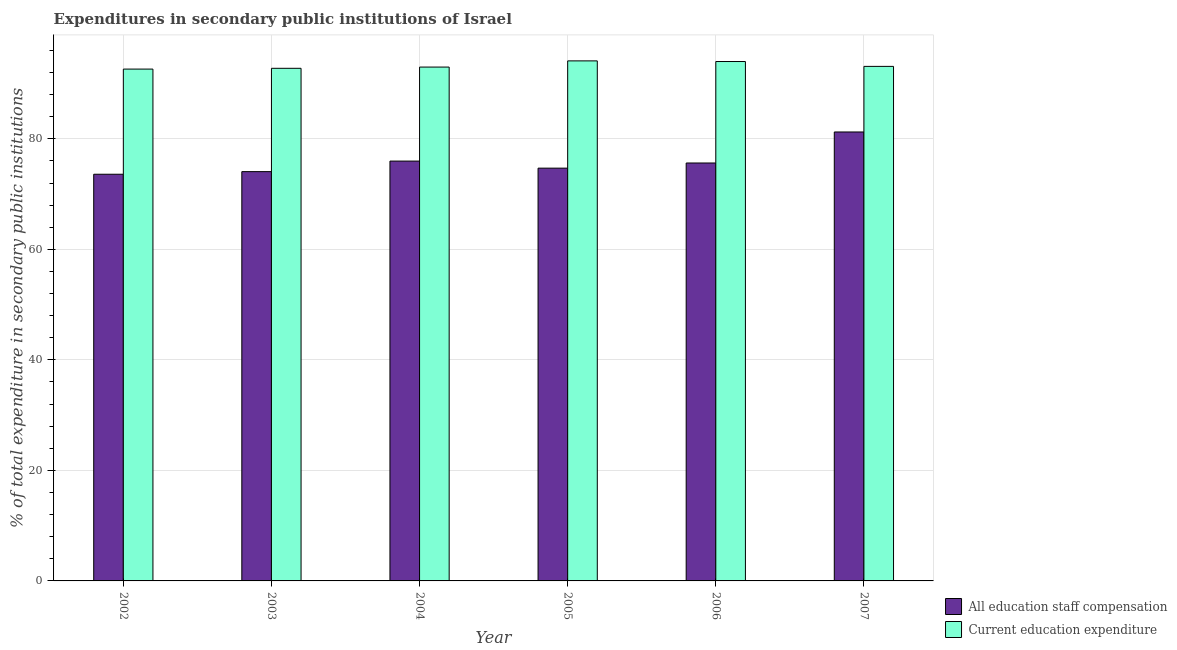How many different coloured bars are there?
Offer a very short reply. 2. How many groups of bars are there?
Your response must be concise. 6. Are the number of bars per tick equal to the number of legend labels?
Give a very brief answer. Yes. How many bars are there on the 2nd tick from the right?
Make the answer very short. 2. In how many cases, is the number of bars for a given year not equal to the number of legend labels?
Provide a succinct answer. 0. What is the expenditure in education in 2002?
Give a very brief answer. 92.62. Across all years, what is the maximum expenditure in education?
Offer a very short reply. 94.11. Across all years, what is the minimum expenditure in staff compensation?
Provide a short and direct response. 73.59. In which year was the expenditure in education maximum?
Provide a short and direct response. 2005. In which year was the expenditure in education minimum?
Your response must be concise. 2002. What is the total expenditure in education in the graph?
Make the answer very short. 559.59. What is the difference between the expenditure in staff compensation in 2006 and that in 2007?
Provide a succinct answer. -5.61. What is the difference between the expenditure in education in 2003 and the expenditure in staff compensation in 2002?
Your answer should be compact. 0.14. What is the average expenditure in education per year?
Keep it short and to the point. 93.27. In the year 2002, what is the difference between the expenditure in education and expenditure in staff compensation?
Provide a short and direct response. 0. In how many years, is the expenditure in staff compensation greater than 56 %?
Provide a short and direct response. 6. What is the ratio of the expenditure in staff compensation in 2003 to that in 2007?
Ensure brevity in your answer.  0.91. Is the expenditure in education in 2006 less than that in 2007?
Make the answer very short. No. What is the difference between the highest and the second highest expenditure in education?
Offer a very short reply. 0.12. What is the difference between the highest and the lowest expenditure in education?
Ensure brevity in your answer.  1.49. What does the 1st bar from the left in 2003 represents?
Offer a terse response. All education staff compensation. What does the 2nd bar from the right in 2003 represents?
Provide a short and direct response. All education staff compensation. How many bars are there?
Offer a terse response. 12. How many years are there in the graph?
Make the answer very short. 6. Are the values on the major ticks of Y-axis written in scientific E-notation?
Your answer should be compact. No. Where does the legend appear in the graph?
Your response must be concise. Bottom right. What is the title of the graph?
Your answer should be very brief. Expenditures in secondary public institutions of Israel. Does "DAC donors" appear as one of the legend labels in the graph?
Ensure brevity in your answer.  No. What is the label or title of the X-axis?
Provide a short and direct response. Year. What is the label or title of the Y-axis?
Keep it short and to the point. % of total expenditure in secondary public institutions. What is the % of total expenditure in secondary public institutions of All education staff compensation in 2002?
Ensure brevity in your answer.  73.59. What is the % of total expenditure in secondary public institutions in Current education expenditure in 2002?
Your answer should be very brief. 92.62. What is the % of total expenditure in secondary public institutions in All education staff compensation in 2003?
Offer a terse response. 74.07. What is the % of total expenditure in secondary public institutions of Current education expenditure in 2003?
Offer a terse response. 92.77. What is the % of total expenditure in secondary public institutions of All education staff compensation in 2004?
Ensure brevity in your answer.  75.97. What is the % of total expenditure in secondary public institutions in Current education expenditure in 2004?
Provide a short and direct response. 92.99. What is the % of total expenditure in secondary public institutions of All education staff compensation in 2005?
Offer a terse response. 74.7. What is the % of total expenditure in secondary public institutions in Current education expenditure in 2005?
Ensure brevity in your answer.  94.11. What is the % of total expenditure in secondary public institutions in All education staff compensation in 2006?
Give a very brief answer. 75.63. What is the % of total expenditure in secondary public institutions in Current education expenditure in 2006?
Keep it short and to the point. 93.99. What is the % of total expenditure in secondary public institutions in All education staff compensation in 2007?
Your answer should be very brief. 81.24. What is the % of total expenditure in secondary public institutions of Current education expenditure in 2007?
Give a very brief answer. 93.11. Across all years, what is the maximum % of total expenditure in secondary public institutions of All education staff compensation?
Provide a succinct answer. 81.24. Across all years, what is the maximum % of total expenditure in secondary public institutions of Current education expenditure?
Your answer should be very brief. 94.11. Across all years, what is the minimum % of total expenditure in secondary public institutions of All education staff compensation?
Give a very brief answer. 73.59. Across all years, what is the minimum % of total expenditure in secondary public institutions in Current education expenditure?
Offer a very short reply. 92.62. What is the total % of total expenditure in secondary public institutions in All education staff compensation in the graph?
Your answer should be very brief. 455.21. What is the total % of total expenditure in secondary public institutions in Current education expenditure in the graph?
Ensure brevity in your answer.  559.59. What is the difference between the % of total expenditure in secondary public institutions of All education staff compensation in 2002 and that in 2003?
Your answer should be compact. -0.47. What is the difference between the % of total expenditure in secondary public institutions of Current education expenditure in 2002 and that in 2003?
Provide a short and direct response. -0.14. What is the difference between the % of total expenditure in secondary public institutions of All education staff compensation in 2002 and that in 2004?
Your response must be concise. -2.38. What is the difference between the % of total expenditure in secondary public institutions in Current education expenditure in 2002 and that in 2004?
Your answer should be compact. -0.36. What is the difference between the % of total expenditure in secondary public institutions of All education staff compensation in 2002 and that in 2005?
Your answer should be compact. -1.1. What is the difference between the % of total expenditure in secondary public institutions of Current education expenditure in 2002 and that in 2005?
Your answer should be very brief. -1.49. What is the difference between the % of total expenditure in secondary public institutions in All education staff compensation in 2002 and that in 2006?
Offer a very short reply. -2.03. What is the difference between the % of total expenditure in secondary public institutions of Current education expenditure in 2002 and that in 2006?
Give a very brief answer. -1.37. What is the difference between the % of total expenditure in secondary public institutions of All education staff compensation in 2002 and that in 2007?
Provide a succinct answer. -7.65. What is the difference between the % of total expenditure in secondary public institutions of Current education expenditure in 2002 and that in 2007?
Provide a succinct answer. -0.49. What is the difference between the % of total expenditure in secondary public institutions of All education staff compensation in 2003 and that in 2004?
Keep it short and to the point. -1.91. What is the difference between the % of total expenditure in secondary public institutions in Current education expenditure in 2003 and that in 2004?
Provide a succinct answer. -0.22. What is the difference between the % of total expenditure in secondary public institutions of All education staff compensation in 2003 and that in 2005?
Give a very brief answer. -0.63. What is the difference between the % of total expenditure in secondary public institutions of Current education expenditure in 2003 and that in 2005?
Offer a very short reply. -1.34. What is the difference between the % of total expenditure in secondary public institutions of All education staff compensation in 2003 and that in 2006?
Offer a terse response. -1.56. What is the difference between the % of total expenditure in secondary public institutions of Current education expenditure in 2003 and that in 2006?
Keep it short and to the point. -1.23. What is the difference between the % of total expenditure in secondary public institutions in All education staff compensation in 2003 and that in 2007?
Ensure brevity in your answer.  -7.18. What is the difference between the % of total expenditure in secondary public institutions of Current education expenditure in 2003 and that in 2007?
Provide a succinct answer. -0.35. What is the difference between the % of total expenditure in secondary public institutions of All education staff compensation in 2004 and that in 2005?
Your answer should be very brief. 1.28. What is the difference between the % of total expenditure in secondary public institutions of Current education expenditure in 2004 and that in 2005?
Ensure brevity in your answer.  -1.12. What is the difference between the % of total expenditure in secondary public institutions of All education staff compensation in 2004 and that in 2006?
Offer a terse response. 0.35. What is the difference between the % of total expenditure in secondary public institutions of Current education expenditure in 2004 and that in 2006?
Give a very brief answer. -1. What is the difference between the % of total expenditure in secondary public institutions in All education staff compensation in 2004 and that in 2007?
Provide a succinct answer. -5.27. What is the difference between the % of total expenditure in secondary public institutions of Current education expenditure in 2004 and that in 2007?
Offer a terse response. -0.12. What is the difference between the % of total expenditure in secondary public institutions of All education staff compensation in 2005 and that in 2006?
Your response must be concise. -0.93. What is the difference between the % of total expenditure in secondary public institutions of Current education expenditure in 2005 and that in 2006?
Your answer should be compact. 0.12. What is the difference between the % of total expenditure in secondary public institutions of All education staff compensation in 2005 and that in 2007?
Your answer should be very brief. -6.54. What is the difference between the % of total expenditure in secondary public institutions of Current education expenditure in 2005 and that in 2007?
Offer a terse response. 1. What is the difference between the % of total expenditure in secondary public institutions of All education staff compensation in 2006 and that in 2007?
Offer a very short reply. -5.61. What is the difference between the % of total expenditure in secondary public institutions in Current education expenditure in 2006 and that in 2007?
Offer a terse response. 0.88. What is the difference between the % of total expenditure in secondary public institutions in All education staff compensation in 2002 and the % of total expenditure in secondary public institutions in Current education expenditure in 2003?
Provide a succinct answer. -19.17. What is the difference between the % of total expenditure in secondary public institutions in All education staff compensation in 2002 and the % of total expenditure in secondary public institutions in Current education expenditure in 2004?
Make the answer very short. -19.39. What is the difference between the % of total expenditure in secondary public institutions of All education staff compensation in 2002 and the % of total expenditure in secondary public institutions of Current education expenditure in 2005?
Your answer should be compact. -20.51. What is the difference between the % of total expenditure in secondary public institutions of All education staff compensation in 2002 and the % of total expenditure in secondary public institutions of Current education expenditure in 2006?
Keep it short and to the point. -20.4. What is the difference between the % of total expenditure in secondary public institutions of All education staff compensation in 2002 and the % of total expenditure in secondary public institutions of Current education expenditure in 2007?
Ensure brevity in your answer.  -19.52. What is the difference between the % of total expenditure in secondary public institutions of All education staff compensation in 2003 and the % of total expenditure in secondary public institutions of Current education expenditure in 2004?
Your answer should be compact. -18.92. What is the difference between the % of total expenditure in secondary public institutions in All education staff compensation in 2003 and the % of total expenditure in secondary public institutions in Current education expenditure in 2005?
Give a very brief answer. -20.04. What is the difference between the % of total expenditure in secondary public institutions in All education staff compensation in 2003 and the % of total expenditure in secondary public institutions in Current education expenditure in 2006?
Provide a short and direct response. -19.93. What is the difference between the % of total expenditure in secondary public institutions in All education staff compensation in 2003 and the % of total expenditure in secondary public institutions in Current education expenditure in 2007?
Your response must be concise. -19.05. What is the difference between the % of total expenditure in secondary public institutions in All education staff compensation in 2004 and the % of total expenditure in secondary public institutions in Current education expenditure in 2005?
Make the answer very short. -18.14. What is the difference between the % of total expenditure in secondary public institutions of All education staff compensation in 2004 and the % of total expenditure in secondary public institutions of Current education expenditure in 2006?
Your answer should be compact. -18.02. What is the difference between the % of total expenditure in secondary public institutions in All education staff compensation in 2004 and the % of total expenditure in secondary public institutions in Current education expenditure in 2007?
Your response must be concise. -17.14. What is the difference between the % of total expenditure in secondary public institutions in All education staff compensation in 2005 and the % of total expenditure in secondary public institutions in Current education expenditure in 2006?
Offer a terse response. -19.29. What is the difference between the % of total expenditure in secondary public institutions of All education staff compensation in 2005 and the % of total expenditure in secondary public institutions of Current education expenditure in 2007?
Give a very brief answer. -18.41. What is the difference between the % of total expenditure in secondary public institutions in All education staff compensation in 2006 and the % of total expenditure in secondary public institutions in Current education expenditure in 2007?
Provide a succinct answer. -17.48. What is the average % of total expenditure in secondary public institutions in All education staff compensation per year?
Your response must be concise. 75.87. What is the average % of total expenditure in secondary public institutions in Current education expenditure per year?
Your response must be concise. 93.27. In the year 2002, what is the difference between the % of total expenditure in secondary public institutions of All education staff compensation and % of total expenditure in secondary public institutions of Current education expenditure?
Your answer should be very brief. -19.03. In the year 2003, what is the difference between the % of total expenditure in secondary public institutions of All education staff compensation and % of total expenditure in secondary public institutions of Current education expenditure?
Offer a very short reply. -18.7. In the year 2004, what is the difference between the % of total expenditure in secondary public institutions of All education staff compensation and % of total expenditure in secondary public institutions of Current education expenditure?
Make the answer very short. -17.01. In the year 2005, what is the difference between the % of total expenditure in secondary public institutions in All education staff compensation and % of total expenditure in secondary public institutions in Current education expenditure?
Your answer should be very brief. -19.41. In the year 2006, what is the difference between the % of total expenditure in secondary public institutions of All education staff compensation and % of total expenditure in secondary public institutions of Current education expenditure?
Make the answer very short. -18.36. In the year 2007, what is the difference between the % of total expenditure in secondary public institutions of All education staff compensation and % of total expenditure in secondary public institutions of Current education expenditure?
Give a very brief answer. -11.87. What is the ratio of the % of total expenditure in secondary public institutions in All education staff compensation in 2002 to that in 2004?
Give a very brief answer. 0.97. What is the ratio of the % of total expenditure in secondary public institutions in Current education expenditure in 2002 to that in 2004?
Keep it short and to the point. 1. What is the ratio of the % of total expenditure in secondary public institutions of All education staff compensation in 2002 to that in 2005?
Your answer should be very brief. 0.99. What is the ratio of the % of total expenditure in secondary public institutions in Current education expenditure in 2002 to that in 2005?
Offer a very short reply. 0.98. What is the ratio of the % of total expenditure in secondary public institutions of All education staff compensation in 2002 to that in 2006?
Provide a short and direct response. 0.97. What is the ratio of the % of total expenditure in secondary public institutions in Current education expenditure in 2002 to that in 2006?
Offer a very short reply. 0.99. What is the ratio of the % of total expenditure in secondary public institutions of All education staff compensation in 2002 to that in 2007?
Your answer should be very brief. 0.91. What is the ratio of the % of total expenditure in secondary public institutions in All education staff compensation in 2003 to that in 2004?
Offer a terse response. 0.97. What is the ratio of the % of total expenditure in secondary public institutions of Current education expenditure in 2003 to that in 2004?
Give a very brief answer. 1. What is the ratio of the % of total expenditure in secondary public institutions of Current education expenditure in 2003 to that in 2005?
Give a very brief answer. 0.99. What is the ratio of the % of total expenditure in secondary public institutions of All education staff compensation in 2003 to that in 2006?
Give a very brief answer. 0.98. What is the ratio of the % of total expenditure in secondary public institutions of Current education expenditure in 2003 to that in 2006?
Make the answer very short. 0.99. What is the ratio of the % of total expenditure in secondary public institutions of All education staff compensation in 2003 to that in 2007?
Your response must be concise. 0.91. What is the ratio of the % of total expenditure in secondary public institutions in All education staff compensation in 2004 to that in 2005?
Provide a succinct answer. 1.02. What is the ratio of the % of total expenditure in secondary public institutions in All education staff compensation in 2004 to that in 2006?
Your response must be concise. 1. What is the ratio of the % of total expenditure in secondary public institutions of Current education expenditure in 2004 to that in 2006?
Give a very brief answer. 0.99. What is the ratio of the % of total expenditure in secondary public institutions in All education staff compensation in 2004 to that in 2007?
Provide a short and direct response. 0.94. What is the ratio of the % of total expenditure in secondary public institutions of Current education expenditure in 2004 to that in 2007?
Offer a very short reply. 1. What is the ratio of the % of total expenditure in secondary public institutions in All education staff compensation in 2005 to that in 2006?
Offer a very short reply. 0.99. What is the ratio of the % of total expenditure in secondary public institutions of All education staff compensation in 2005 to that in 2007?
Give a very brief answer. 0.92. What is the ratio of the % of total expenditure in secondary public institutions of Current education expenditure in 2005 to that in 2007?
Your answer should be very brief. 1.01. What is the ratio of the % of total expenditure in secondary public institutions of All education staff compensation in 2006 to that in 2007?
Ensure brevity in your answer.  0.93. What is the ratio of the % of total expenditure in secondary public institutions in Current education expenditure in 2006 to that in 2007?
Your answer should be very brief. 1.01. What is the difference between the highest and the second highest % of total expenditure in secondary public institutions in All education staff compensation?
Give a very brief answer. 5.27. What is the difference between the highest and the second highest % of total expenditure in secondary public institutions in Current education expenditure?
Offer a very short reply. 0.12. What is the difference between the highest and the lowest % of total expenditure in secondary public institutions of All education staff compensation?
Give a very brief answer. 7.65. What is the difference between the highest and the lowest % of total expenditure in secondary public institutions in Current education expenditure?
Your response must be concise. 1.49. 